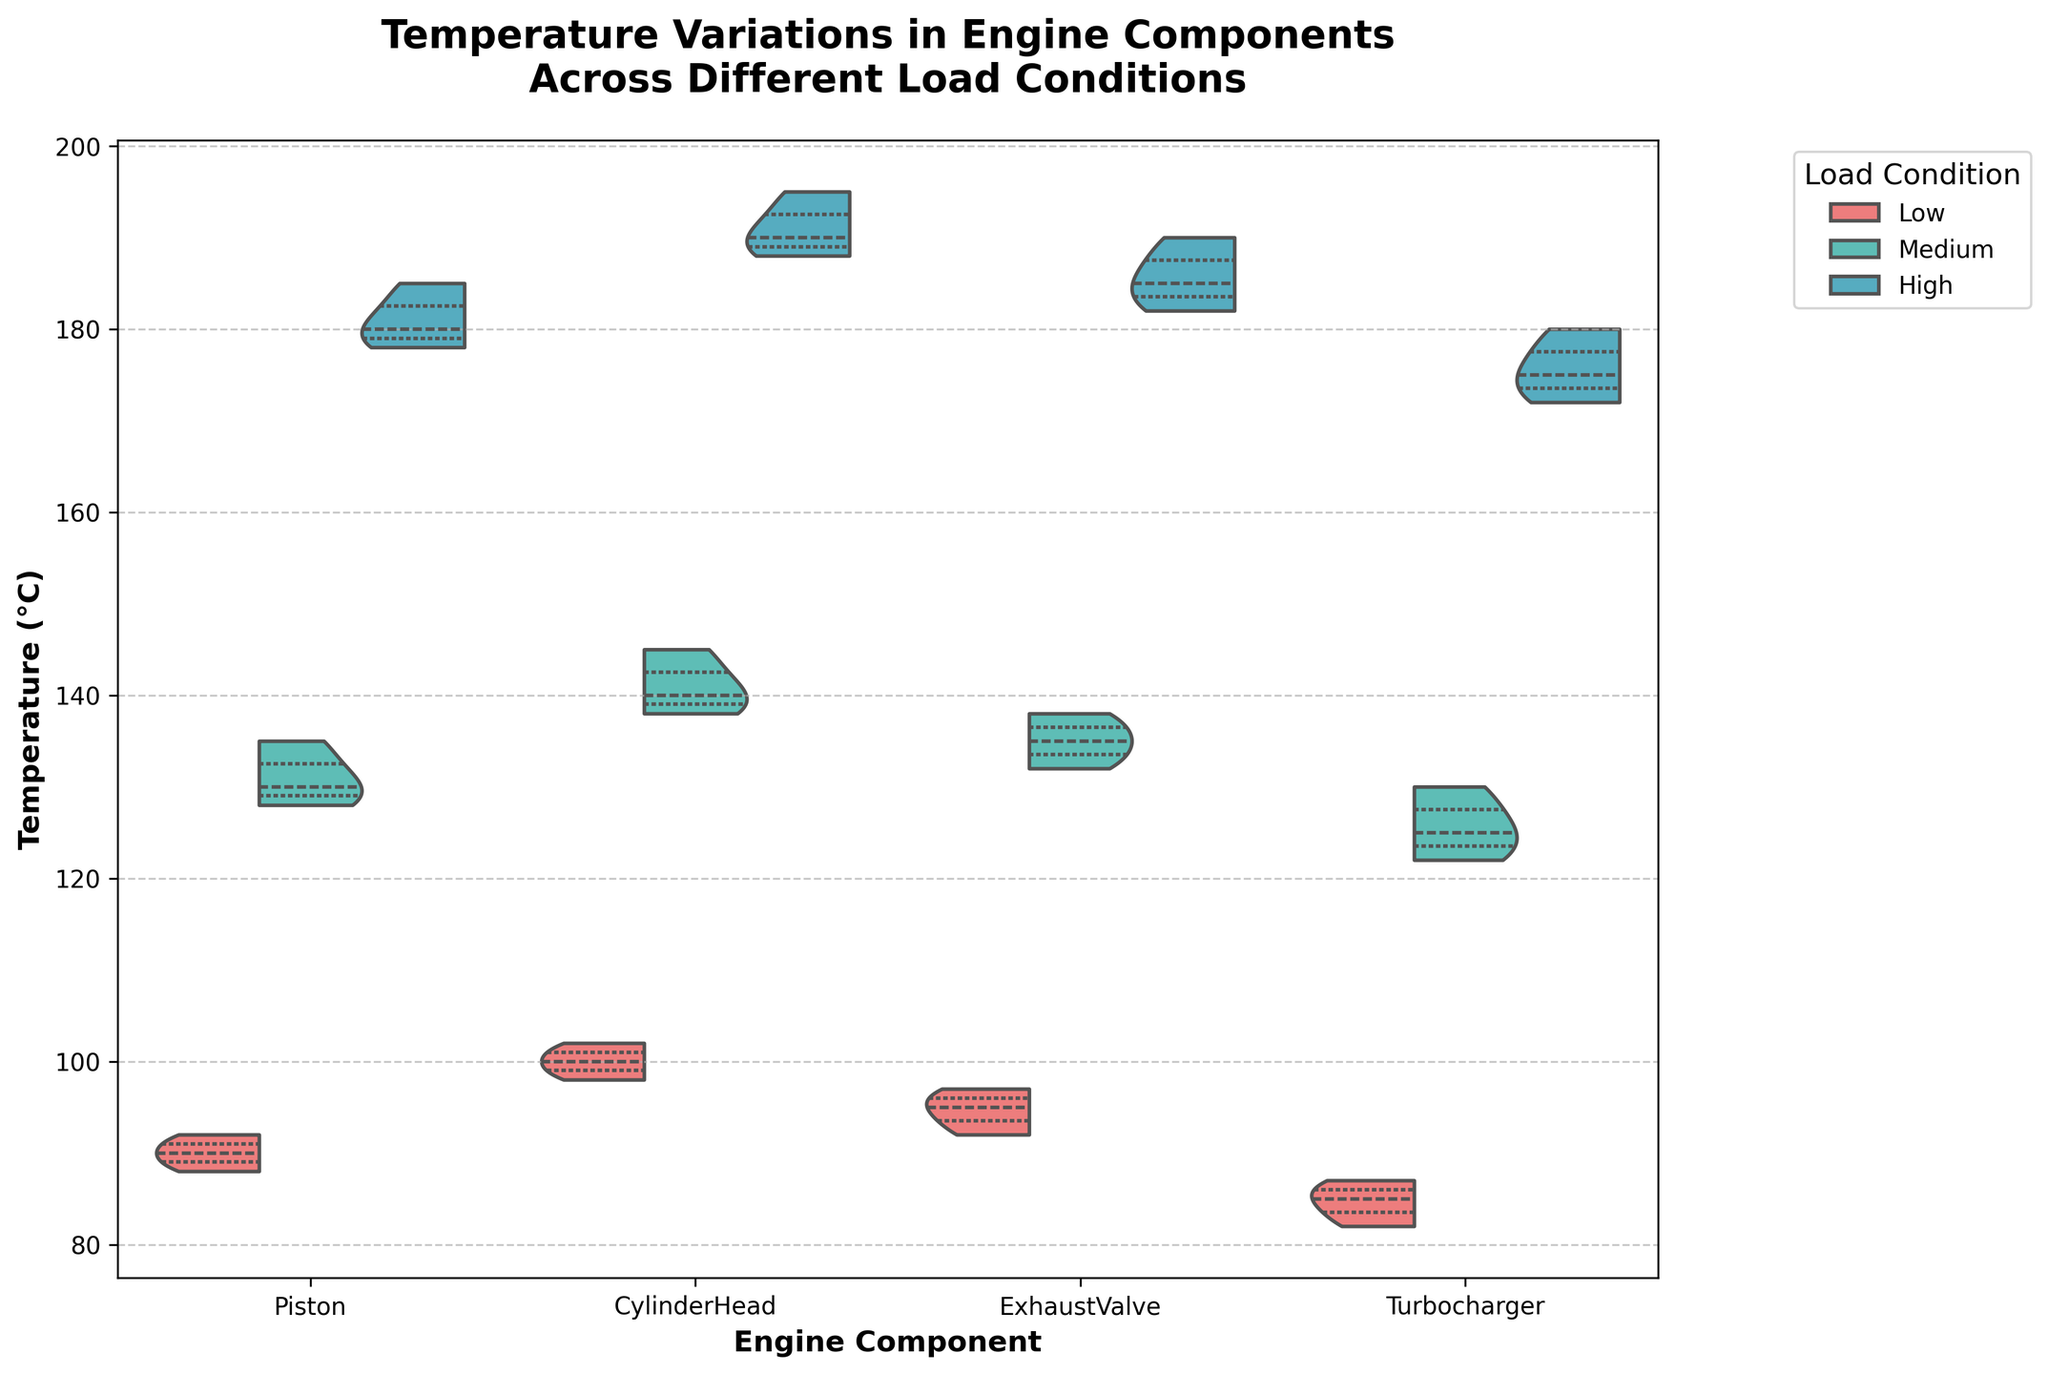What's the title of the chart? The title of the chart is displayed at the top and it summarizes what the chart is about. In this case, it mentions temperature variations in engine components across different load conditions.
Answer: Temperature Variations in Engine Components Across Different Load Conditions What are the engine components displayed on the x-axis? The engine components are labeled along the x-axis of the chart. These represent the different engine parts being analyzed.
Answer: Piston, Cylinder Head, Exhaust Valve, Turbocharger Which load condition has the highest median temperature for the piston component? To find this, look at the median line within the violin plot for each load condition. For the piston, the highest median line appears in the highest load condition.
Answer: High How does the temperature distribution for the turbocharger compare between low and high load conditions? Comparing the split violin plots for the turbocharger under low and high load conditions, observe the spread and central tendency (median line) of temperatures. The high load condition has a higher median and a wider spread of temperatures compared to the low load condition.
Answer: Higher temperature range and median in high load condition What are the temperature quartiles for the exhaust valve under medium load condition? The quartiles can be inferred from the inner lines in the violin plot. For the exhaust valve under medium load, observe where the lines divide the distribution. The lower quartile (Q1) is around 132°C, the median (Q2) is around 135°C, and the upper quartile (Q3) is around 138°C.
Answer: Q1: 132°C, Q2: 135°C, Q3: 138°C Which component shows the smallest temperature range across all load conditions? To find this, compare the ranges of the temperature distributions for all components across low, medium, and high load conditions. The turbocharger shows the smallest overall range, particularly in low load conditions with values between 82°C and 87°C.
Answer: Turbocharger For the cylinder head component, how much does the median temperature increase from low to high load conditions? Determine the median temperature for cylinder head under low and high load conditions by observing the median lines in the violin plot, then calculate the difference. The medians are approximately 100°C in low and 190°C in high, so the increase is 190°C - 100°C = 90°C.
Answer: 90°C Which load condition has the highest overall temperature spread for all components? To answer this, visually inspect the spread and range of temperatures for each load condition across all components. The high load condition generally exhibits the widest spreads in the violin plots.
Answer: High What's the highest temperature recorded for the exhaust valve under any load condition? Locate the highest point on the violin plots for the exhaust valve under all load conditions. The highest temperature is recorded under the high load condition, reaching up to 190°C.
Answer: 190°C Is the temperature variation for the piston more consistent in low or medium load conditions? Assess consistency by looking at the spread of the violin plots. A more consistent variation will show a narrower plot. For the piston, the medium load condition has a wider spread than the low load, indicating less consistency.
Answer: Low load condition 